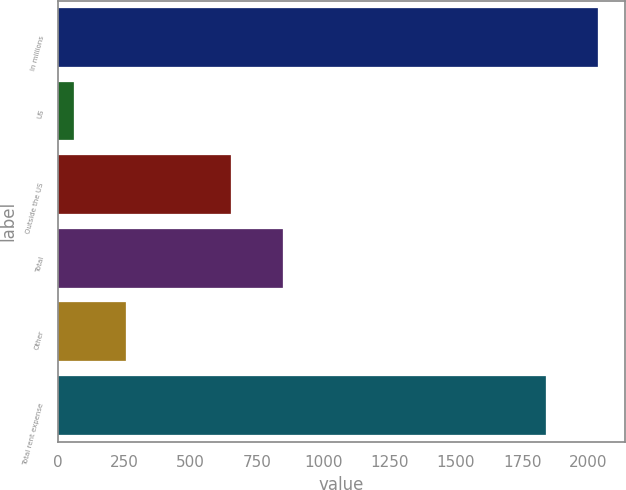<chart> <loc_0><loc_0><loc_500><loc_500><bar_chart><fcel>In millions<fcel>US<fcel>Outside the US<fcel>Total<fcel>Other<fcel>Total rent expense<nl><fcel>2034.58<fcel>59.2<fcel>652.7<fcel>848.28<fcel>254.78<fcel>1839<nl></chart> 